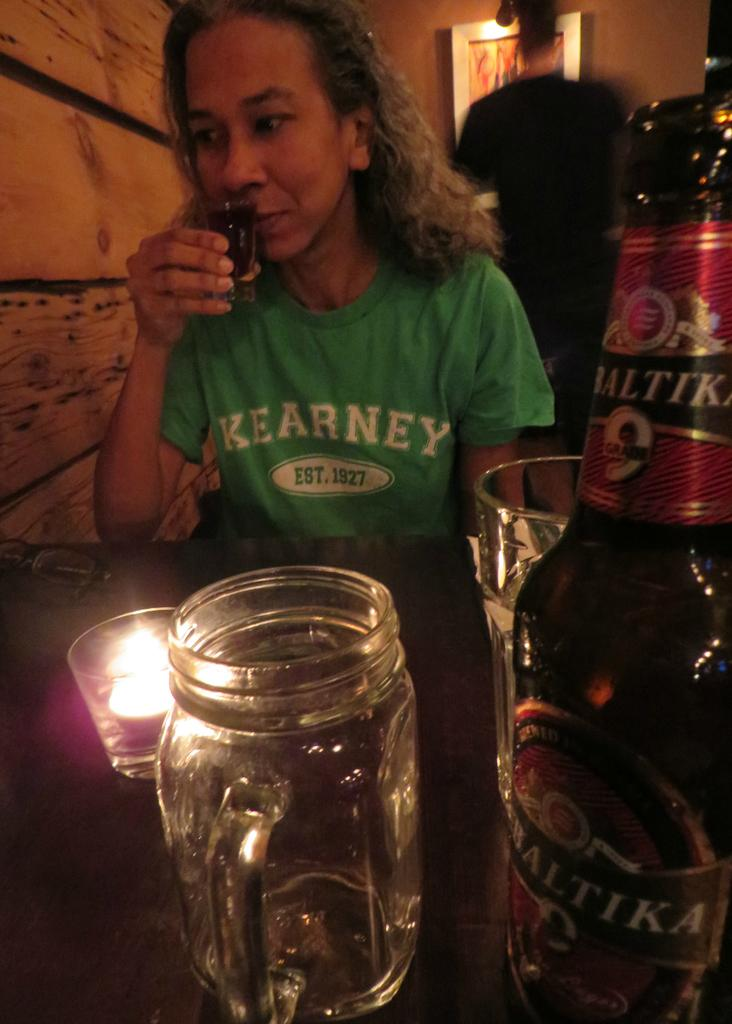<image>
Write a terse but informative summary of the picture. the name Kearney is on the green shirt 